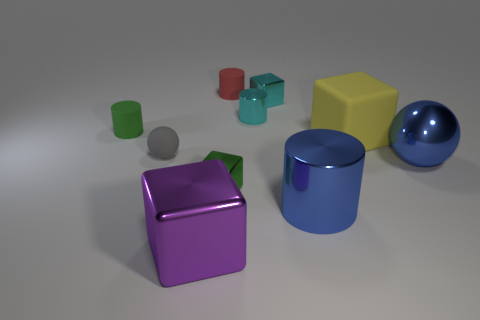What size is the metallic cylinder that is in front of the large yellow object?
Offer a terse response. Large. There is a tiny metallic cylinder; are there any rubber objects on the left side of it?
Your answer should be compact. Yes. How many gray things are either rubber cubes or cylinders?
Your response must be concise. 0. Is the green cylinder made of the same material as the large block on the right side of the small cyan shiny cylinder?
Ensure brevity in your answer.  Yes. The cyan metallic thing that is the same shape as the tiny green matte thing is what size?
Offer a very short reply. Small. What material is the large yellow cube?
Your answer should be very brief. Rubber. What is the material of the ball that is to the right of the shiny block that is behind the cylinder that is left of the tiny red matte object?
Your answer should be very brief. Metal. Is the size of the green thing to the left of the big metal cube the same as the green object that is in front of the matte block?
Give a very brief answer. Yes. How many other things are the same material as the small green cylinder?
Your answer should be very brief. 3. What number of matte things are either purple things or cyan cylinders?
Ensure brevity in your answer.  0. 